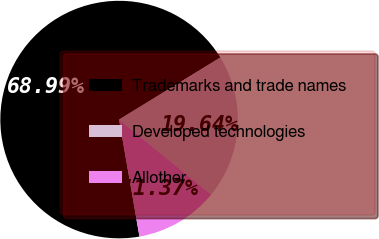Convert chart. <chart><loc_0><loc_0><loc_500><loc_500><pie_chart><fcel>Trademarks and trade names<fcel>Developed technologies<fcel>Allother<nl><fcel>68.99%<fcel>19.64%<fcel>11.37%<nl></chart> 